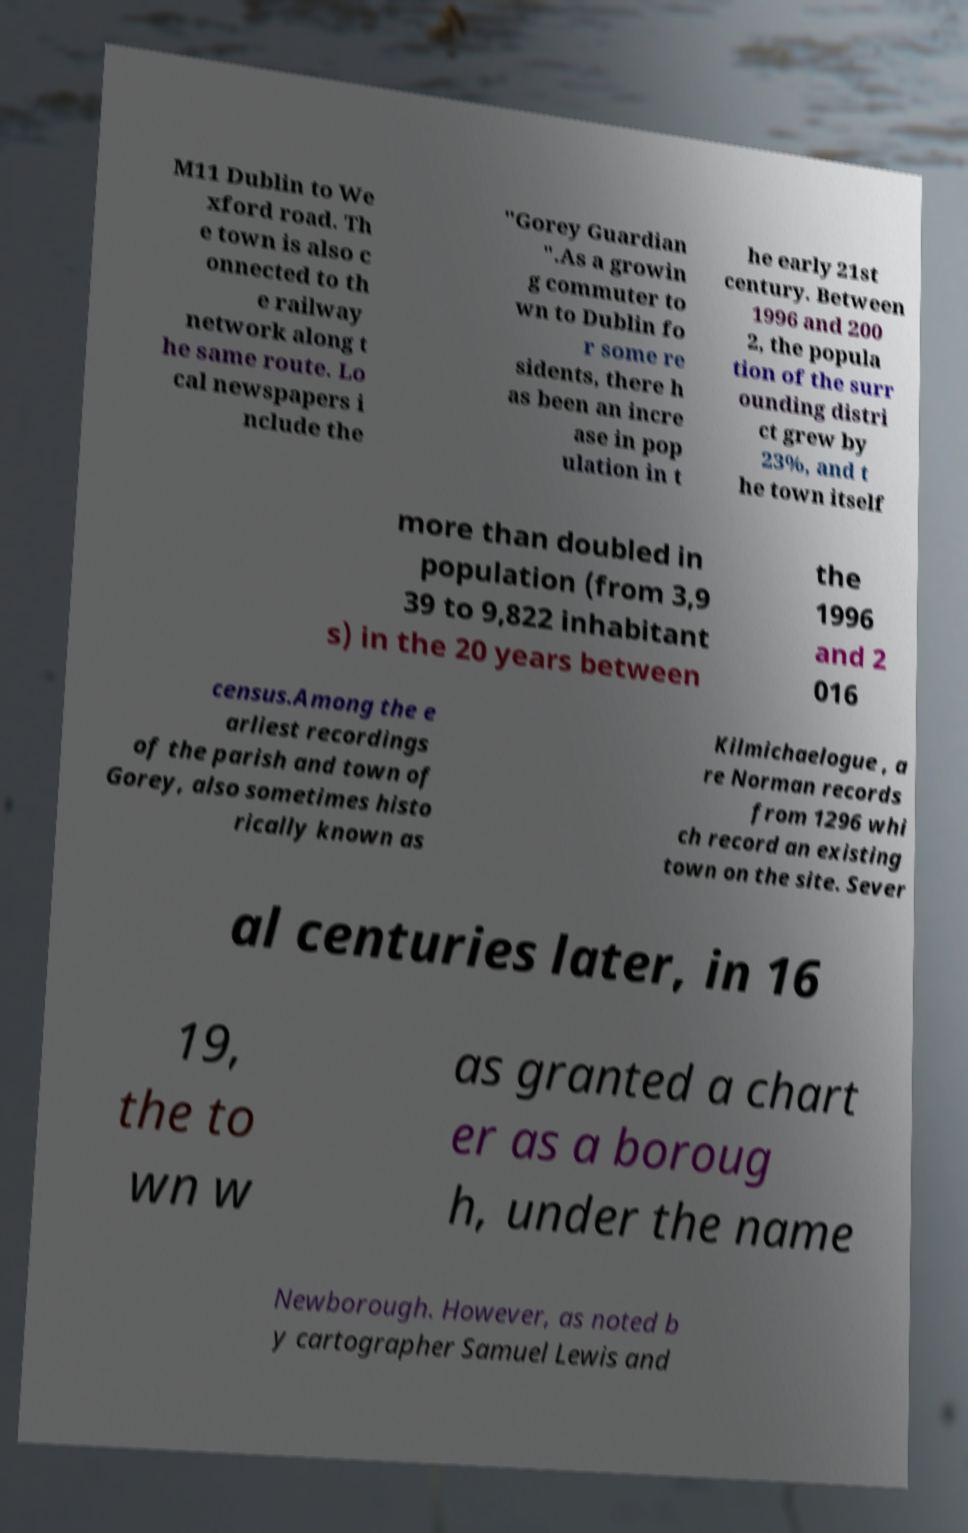Could you assist in decoding the text presented in this image and type it out clearly? M11 Dublin to We xford road. Th e town is also c onnected to th e railway network along t he same route. Lo cal newspapers i nclude the "Gorey Guardian ".As a growin g commuter to wn to Dublin fo r some re sidents, there h as been an incre ase in pop ulation in t he early 21st century. Between 1996 and 200 2, the popula tion of the surr ounding distri ct grew by 23%, and t he town itself more than doubled in population (from 3,9 39 to 9,822 inhabitant s) in the 20 years between the 1996 and 2 016 census.Among the e arliest recordings of the parish and town of Gorey, also sometimes histo rically known as Kilmichaelogue , a re Norman records from 1296 whi ch record an existing town on the site. Sever al centuries later, in 16 19, the to wn w as granted a chart er as a boroug h, under the name Newborough. However, as noted b y cartographer Samuel Lewis and 